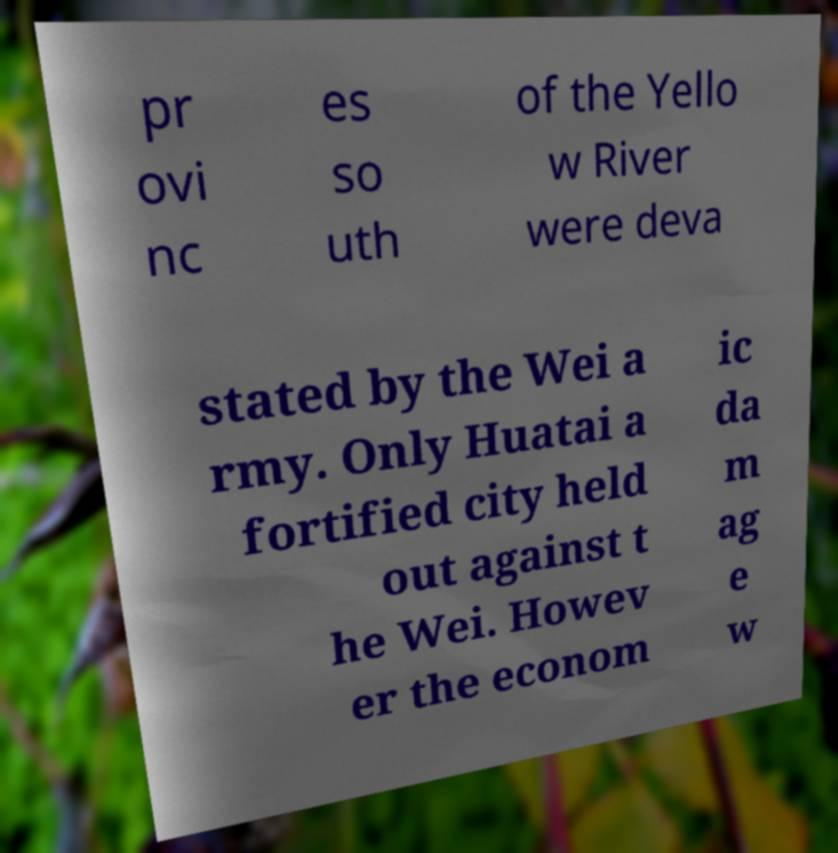Please read and relay the text visible in this image. What does it say? pr ovi nc es so uth of the Yello w River were deva stated by the Wei a rmy. Only Huatai a fortified city held out against t he Wei. Howev er the econom ic da m ag e w 